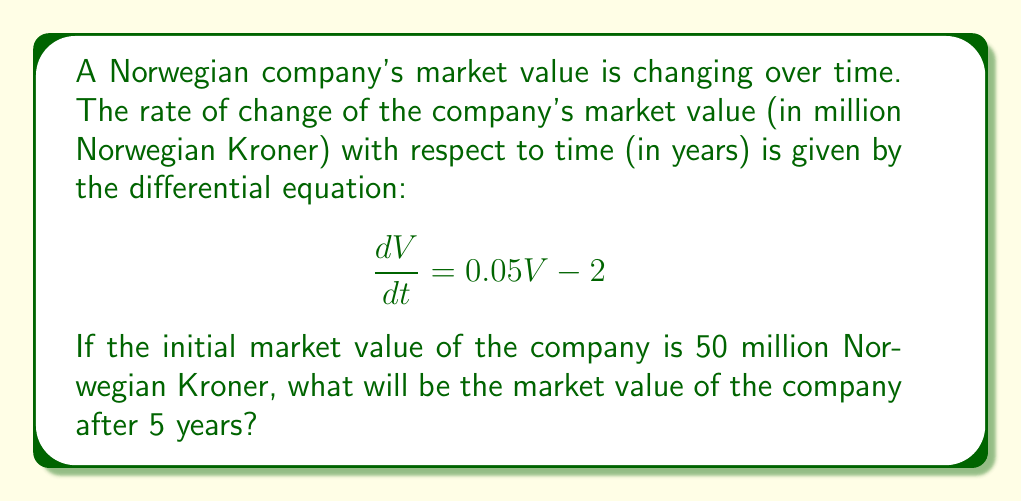Can you solve this math problem? To solve this problem, we need to follow these steps:

1) The given differential equation is:
   $$\frac{dV}{dt} = 0.05V - 2$$

2) This is a first-order linear differential equation. We can solve it using the integrating factor method.

3) The integrating factor is $e^{\int 0.05 dt} = e^{0.05t}$

4) Multiplying both sides of the equation by the integrating factor:
   $$e^{0.05t}\frac{dV}{dt} + 0.05Ve^{0.05t} = 2e^{0.05t}$$

5) The left side is now the derivative of $Ve^{0.05t}$, so we can write:
   $$\frac{d}{dt}(Ve^{0.05t}) = 2e^{0.05t}$$

6) Integrating both sides:
   $$Ve^{0.05t} = 40e^{0.05t} + C$$

7) Solving for V:
   $$V = 40 + Ce^{-0.05t}$$

8) Using the initial condition V(0) = 50:
   $$50 = 40 + C$$
   $$C = 10$$

9) Therefore, the general solution is:
   $$V = 40 + 10e^{-0.05t}$$

10) To find the value after 5 years, we substitute t = 5:
    $$V(5) = 40 + 10e^{-0.05(5)} = 40 + 10e^{-0.25} \approx 47.80$$
Answer: The market value of the company after 5 years will be approximately 47.80 million Norwegian Kroner. 